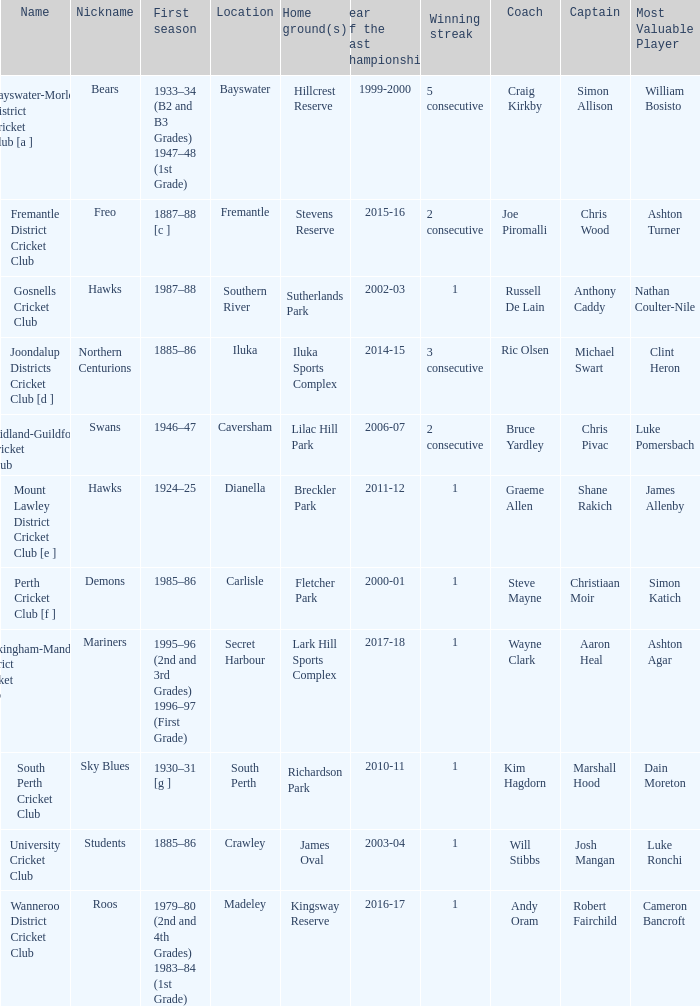What is the dates where Hillcrest Reserve is the home grounds? 1933–34 (B2 and B3 Grades) 1947–48 (1st Grade). 